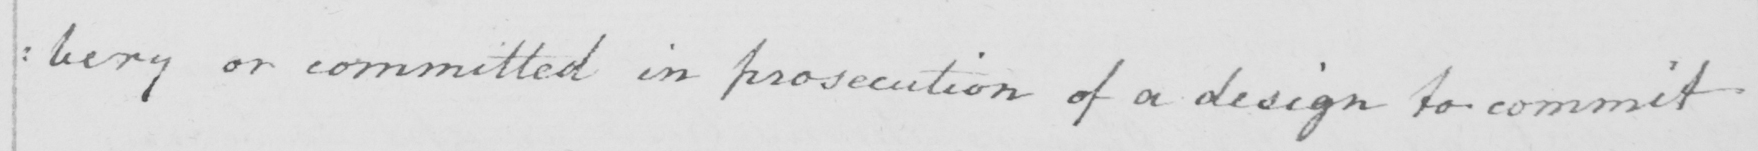Please transcribe the handwritten text in this image. : bery or committed in prosecution of a design to commit 